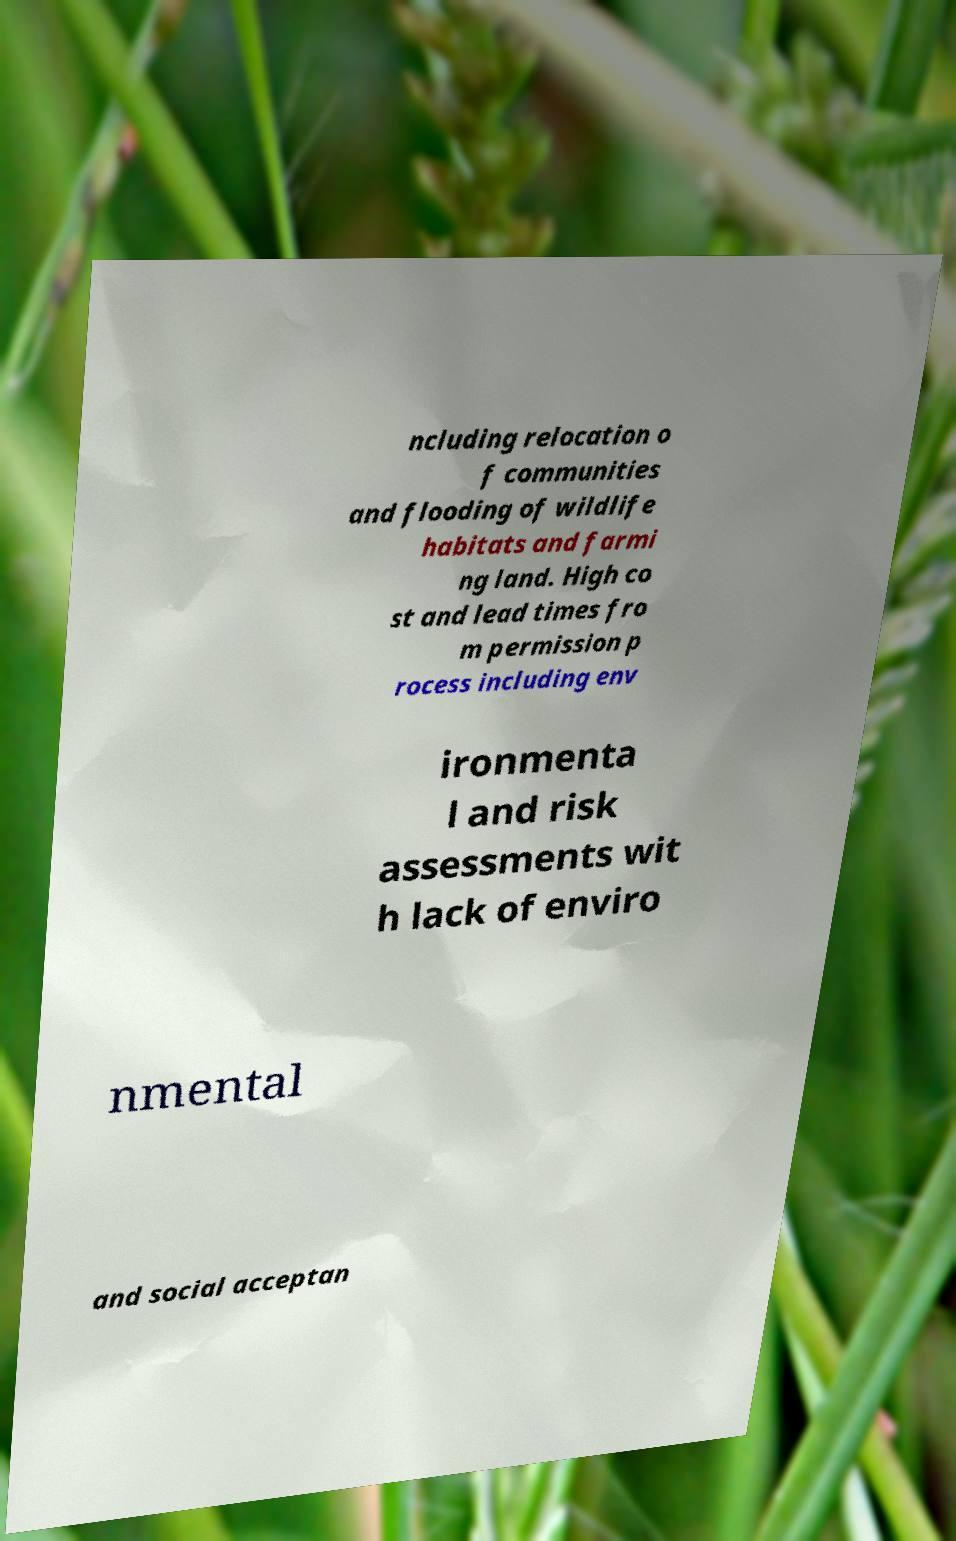Can you accurately transcribe the text from the provided image for me? ncluding relocation o f communities and flooding of wildlife habitats and farmi ng land. High co st and lead times fro m permission p rocess including env ironmenta l and risk assessments wit h lack of enviro nmental and social acceptan 